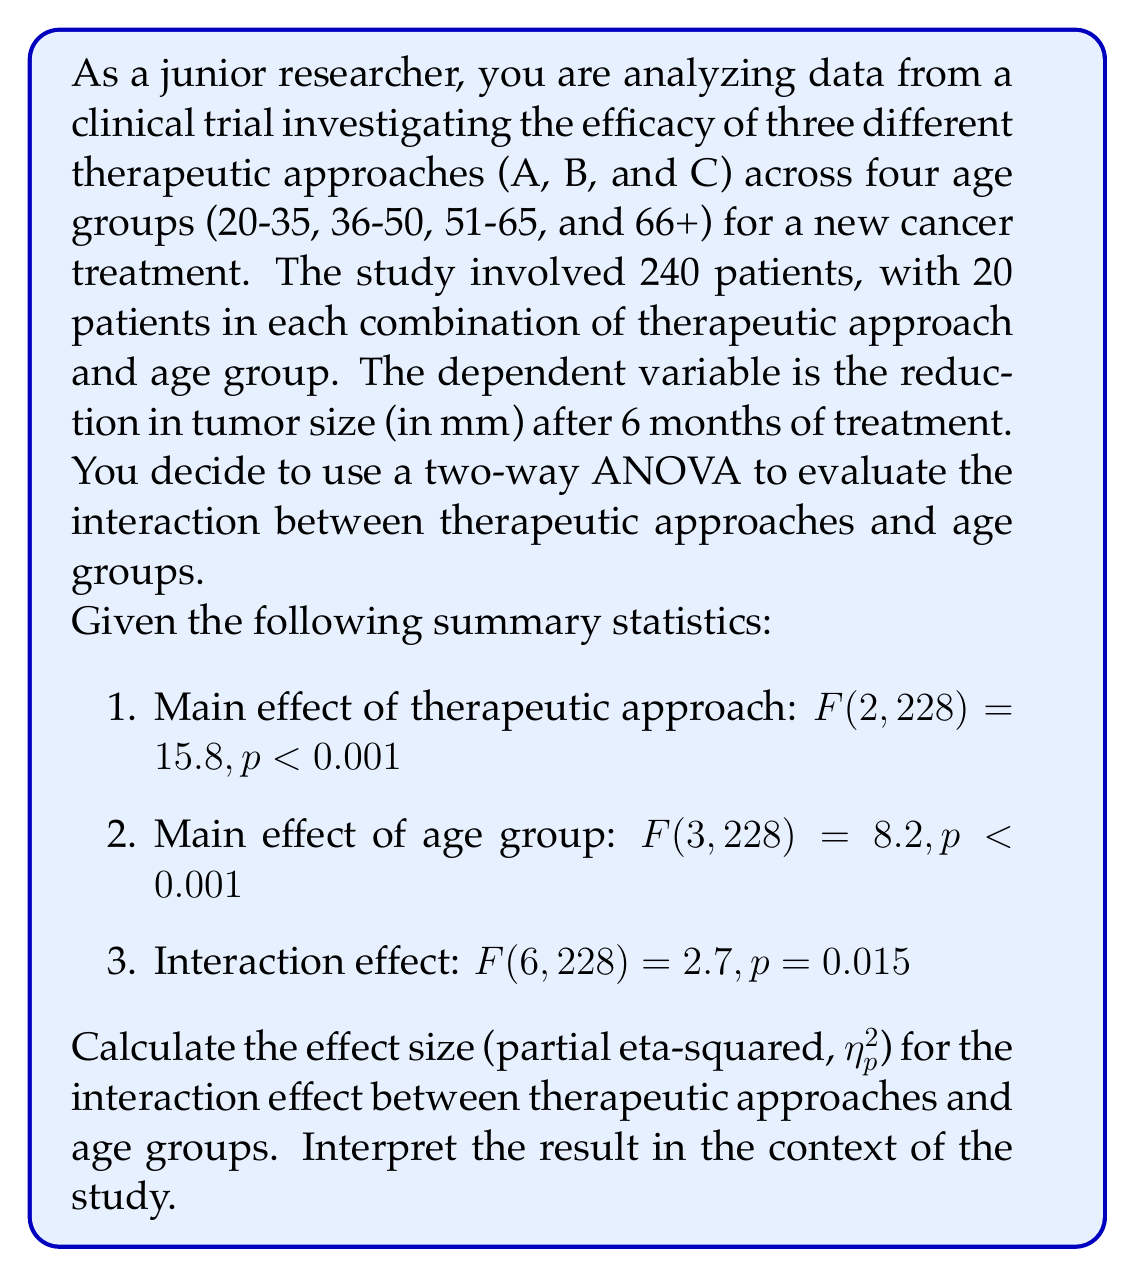Help me with this question. To calculate the partial eta-squared ($\eta_p^2$) for the interaction effect, we need to use the following formula:

$$\eta_p^2 = \frac{SS_\text{effect}}{SS_\text{effect} + SS_\text{error}}$$

Where $SS_\text{effect}$ is the sum of squares for the effect (interaction in this case) and $SS_\text{error}$ is the sum of squares for the error.

We can derive these values from the given F-statistic using the following relationships:

1. $F = \frac{MS_\text{effect}}{MS_\text{error}}$
2. $MS_\text{effect} = \frac{SS_\text{effect}}{df_\text{effect}}$
3. $MS_\text{error} = \frac{SS_\text{error}}{df_\text{error}}$

For the interaction effect, we have:
$F(6, 228) = 2.7$

Step 1: Calculate $SS_\text{effect}$
$SS_\text{effect} = MS_\text{effect} \times df_\text{effect}$
$MS_\text{effect} = F \times MS_\text{error}$
$SS_\text{effect} = (F \times MS_\text{error}) \times df_\text{effect}$
$SS_\text{effect} = (2.7 \times MS_\text{error}) \times 6$

Step 2: Calculate $SS_\text{error}$
$SS_\text{error} = MS_\text{error} \times df_\text{error}$
$SS_\text{error} = MS_\text{error} \times 228$

Step 3: Substitute into the $\eta_p^2$ formula
$$\eta_p^2 = \frac{(2.7 \times MS_\text{error}) \times 6}{(2.7 \times MS_\text{error}) \times 6 + MS_\text{error} \times 228}$$

Step 4: Simplify
$$\eta_p^2 = \frac{16.2}{16.2 + 228} = \frac{16.2}{244.2} \approx 0.0663$$

Interpretation: The partial eta-squared value of 0.0663 indicates that approximately 6.63% of the variance in tumor size reduction can be attributed to the interaction between therapeutic approaches and age groups, after controlling for the main effects. This is considered a small to medium effect size according to Cohen's guidelines (small: 0.01, medium: 0.06, large: 0.14).

In the context of the study, this suggests that the effectiveness of the different therapeutic approaches varies somewhat across age groups, but the interaction effect is not particularly strong. As a junior researcher, you might conclude that while there is evidence for an interaction, it may not be the primary focus of your findings. The main effects of therapeutic approach and age group appear to be more substantial, given their higher F-values.
Answer: $\eta_p^2 \approx 0.0663$ or 6.63% 